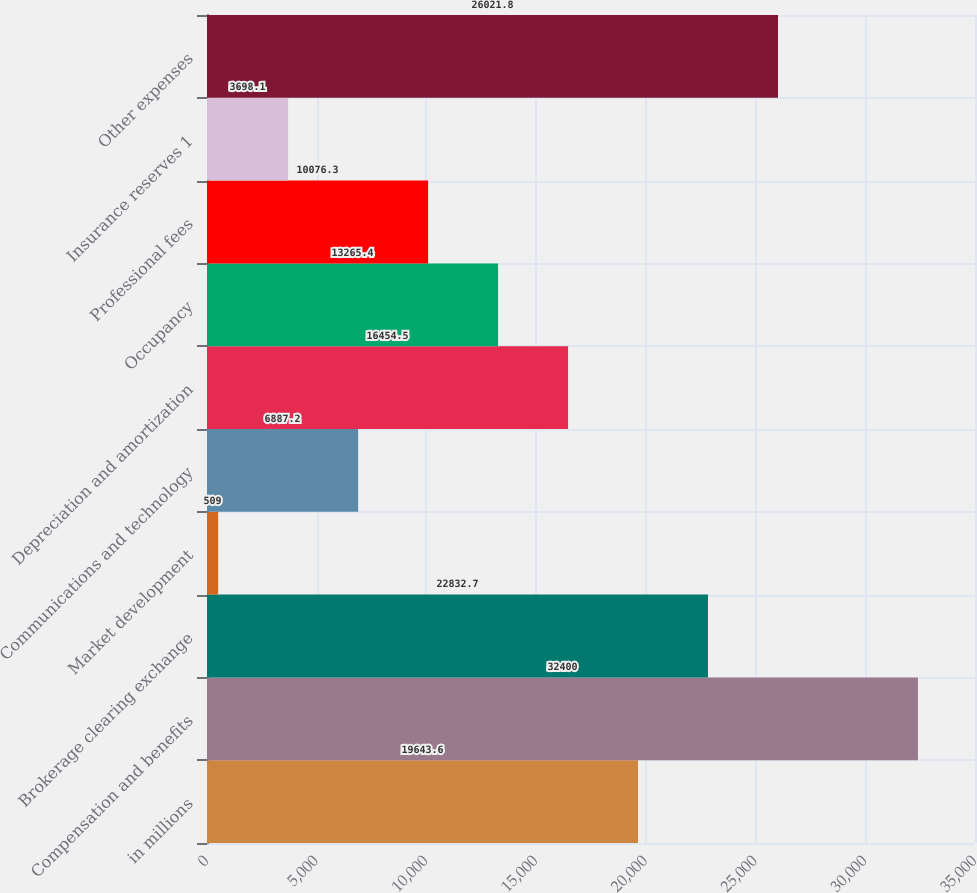<chart> <loc_0><loc_0><loc_500><loc_500><bar_chart><fcel>in millions<fcel>Compensation and benefits<fcel>Brokerage clearing exchange<fcel>Market development<fcel>Communications and technology<fcel>Depreciation and amortization<fcel>Occupancy<fcel>Professional fees<fcel>Insurance reserves 1<fcel>Other expenses<nl><fcel>19643.6<fcel>32400<fcel>22832.7<fcel>509<fcel>6887.2<fcel>16454.5<fcel>13265.4<fcel>10076.3<fcel>3698.1<fcel>26021.8<nl></chart> 